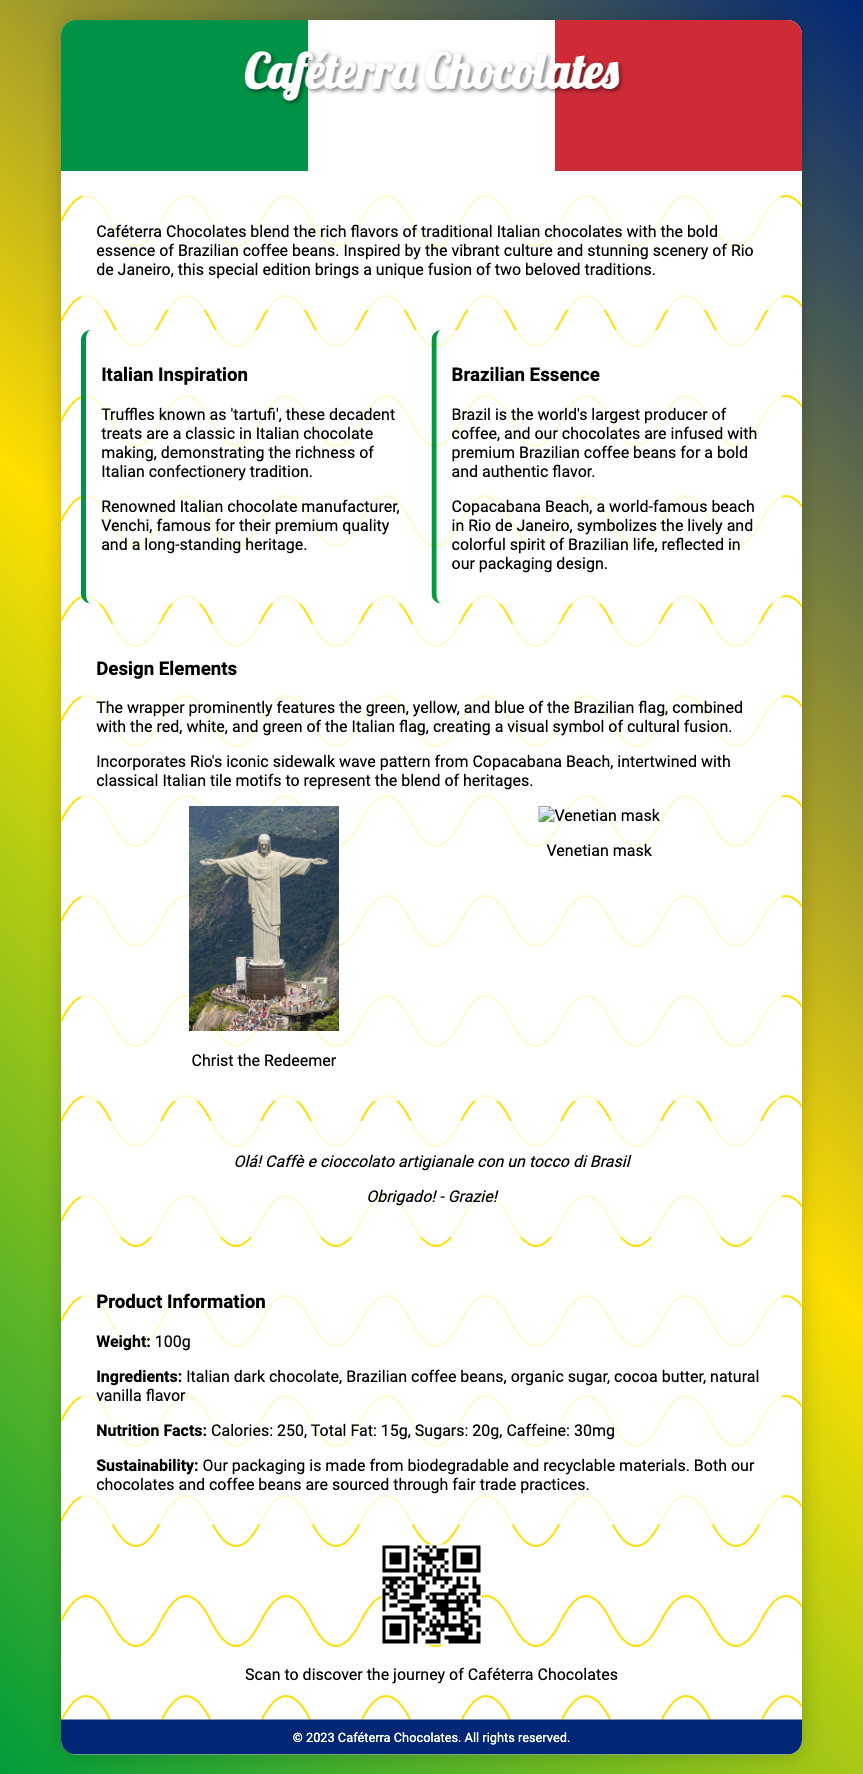What is the product name? The product name is prominently displayed in the header of the document.
Answer: Caféterra Chocolates What are the main ingredients? The ingredients are listed in the product information section of the document.
Answer: Italian dark chocolate, Brazilian coffee beans, organic sugar, cocoa butter, natural vanilla flavor What is the weight of the product? The weight is specified in the product information section.
Answer: 100g What is the tagline? The tagline is presented under the product name in the header.
Answer: Where Italy meets Brazil What colors are featured in the design elements? The design elements include mentions of the colors from both flags as detailed in the wrapper description.
Answer: Green, yellow, blue, red, white What is the caffeine content? The caffeine content is noted in the nutrition facts within the product information section.
Answer: 30mg Which Brazilian beach is mentioned? The mention of Copacabana Beach reflects the cultural aspect of the product.
Answer: Copacabana Beach What type of chocolate is used? The type of chocolate is clearly listed in the ingredients section.
Answer: Italian dark chocolate What is the packaging sustainability? The sustainability information specifies the type of materials used for the packaging and sourcing.
Answer: Biodegradable and recyclable materials 